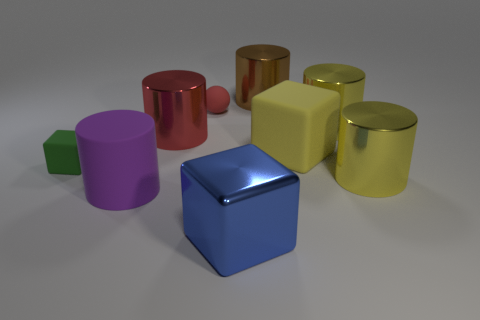Subtract all large red cylinders. How many cylinders are left? 4 Subtract all large brown rubber blocks. Subtract all purple rubber things. How many objects are left? 8 Add 4 yellow metal objects. How many yellow metal objects are left? 6 Add 3 large brown things. How many large brown things exist? 4 Subtract all red cylinders. How many cylinders are left? 4 Subtract 0 blue balls. How many objects are left? 9 Subtract all blocks. How many objects are left? 6 Subtract all gray cylinders. Subtract all brown blocks. How many cylinders are left? 5 Subtract all red spheres. How many purple blocks are left? 0 